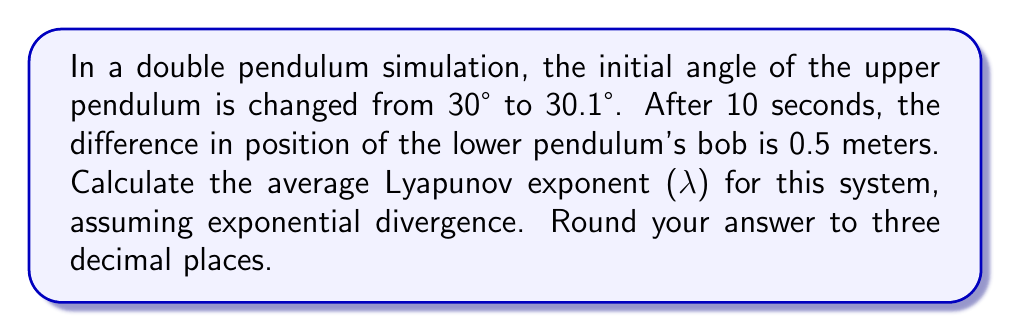Can you solve this math problem? To solve this problem, we'll use the formula for the Lyapunov exponent:

$$λ = \frac{1}{t} \ln\left(\frac{d(t)}{d(0)}\right)$$

Where:
- $λ$ is the Lyapunov exponent
- $t$ is the time elapsed
- $d(t)$ is the final separation between trajectories
- $d(0)$ is the initial separation between trajectories

Step 1: Determine the values for our variables
- $t = 10$ seconds
- $d(t) = 0.5$ meters
- $d(0) = 30.1° - 30° = 0.1°$

Step 2: Convert the initial separation from degrees to radians
$$d(0) = 0.1° \times \frac{\pi}{180°} ≈ 0.001745 \text{ radians}$$

Step 3: Substitute these values into the Lyapunov exponent formula
$$λ = \frac{1}{10} \ln\left(\frac{0.5}{0.001745}\right)$$

Step 4: Calculate the result
$$λ = 0.1 \ln(286.53) ≈ 0.1 \times 5.6579 ≈ 0.56579$$

Step 5: Round to three decimal places
$$λ ≈ 0.566$$
Answer: 0.566 